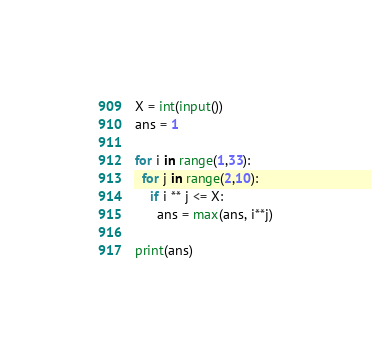<code> <loc_0><loc_0><loc_500><loc_500><_Python_>X = int(input())
ans = 1

for i in range(1,33):
  for j in range(2,10):
    if i ** j <= X:
      ans = max(ans, i**j)

print(ans)</code> 